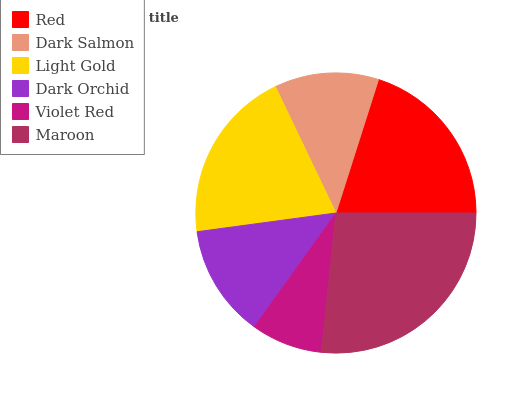Is Violet Red the minimum?
Answer yes or no. Yes. Is Maroon the maximum?
Answer yes or no. Yes. Is Dark Salmon the minimum?
Answer yes or no. No. Is Dark Salmon the maximum?
Answer yes or no. No. Is Red greater than Dark Salmon?
Answer yes or no. Yes. Is Dark Salmon less than Red?
Answer yes or no. Yes. Is Dark Salmon greater than Red?
Answer yes or no. No. Is Red less than Dark Salmon?
Answer yes or no. No. Is Light Gold the high median?
Answer yes or no. Yes. Is Dark Orchid the low median?
Answer yes or no. Yes. Is Red the high median?
Answer yes or no. No. Is Dark Salmon the low median?
Answer yes or no. No. 